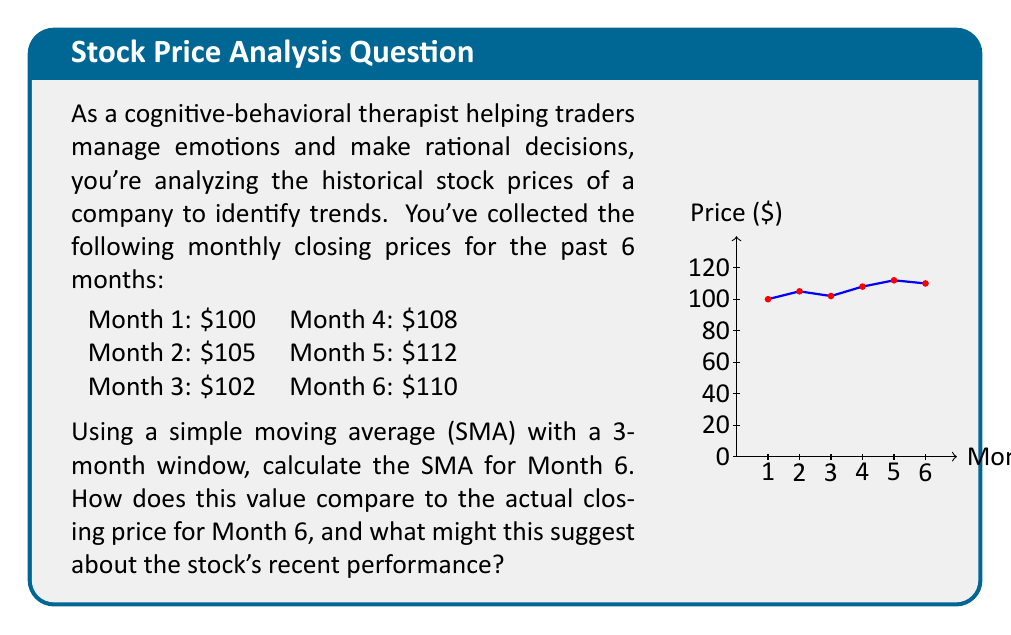Teach me how to tackle this problem. To solve this problem, we'll follow these steps:

1) First, let's recall the formula for a Simple Moving Average (SMA):

   $$ SMA_n = \frac{P_1 + P_2 + ... + P_n}{n} $$

   Where $n$ is the number of periods (in this case, 3 months), and $P_i$ are the prices.

2) For Month 6, we need to use the prices from Months 4, 5, and 6:

   Month 4: $108
   Month 5: $112
   Month 6: $110

3) Let's plug these values into our SMA formula:

   $$ SMA_3 = \frac{108 + 112 + 110}{3} $$

4) Now, let's calculate:

   $$ SMA_3 = \frac{330}{3} = 110 $$

5) The SMA for Month 6 is $110.

6) Comparing this to the actual closing price for Month 6, which was also $110, we see that they are equal.

7) This suggests that the stock's recent performance is in line with its short-term trend. The fact that the actual price matches the SMA indicates that the stock is neither overbought nor oversold in the short term, based on this simple analysis.

8) However, it's important to note that this is just one data point and should be considered alongside other factors and longer-term trends for a more comprehensive analysis.
Answer: SMA = $110, equal to Month 6 closing price, suggesting stable short-term performance. 